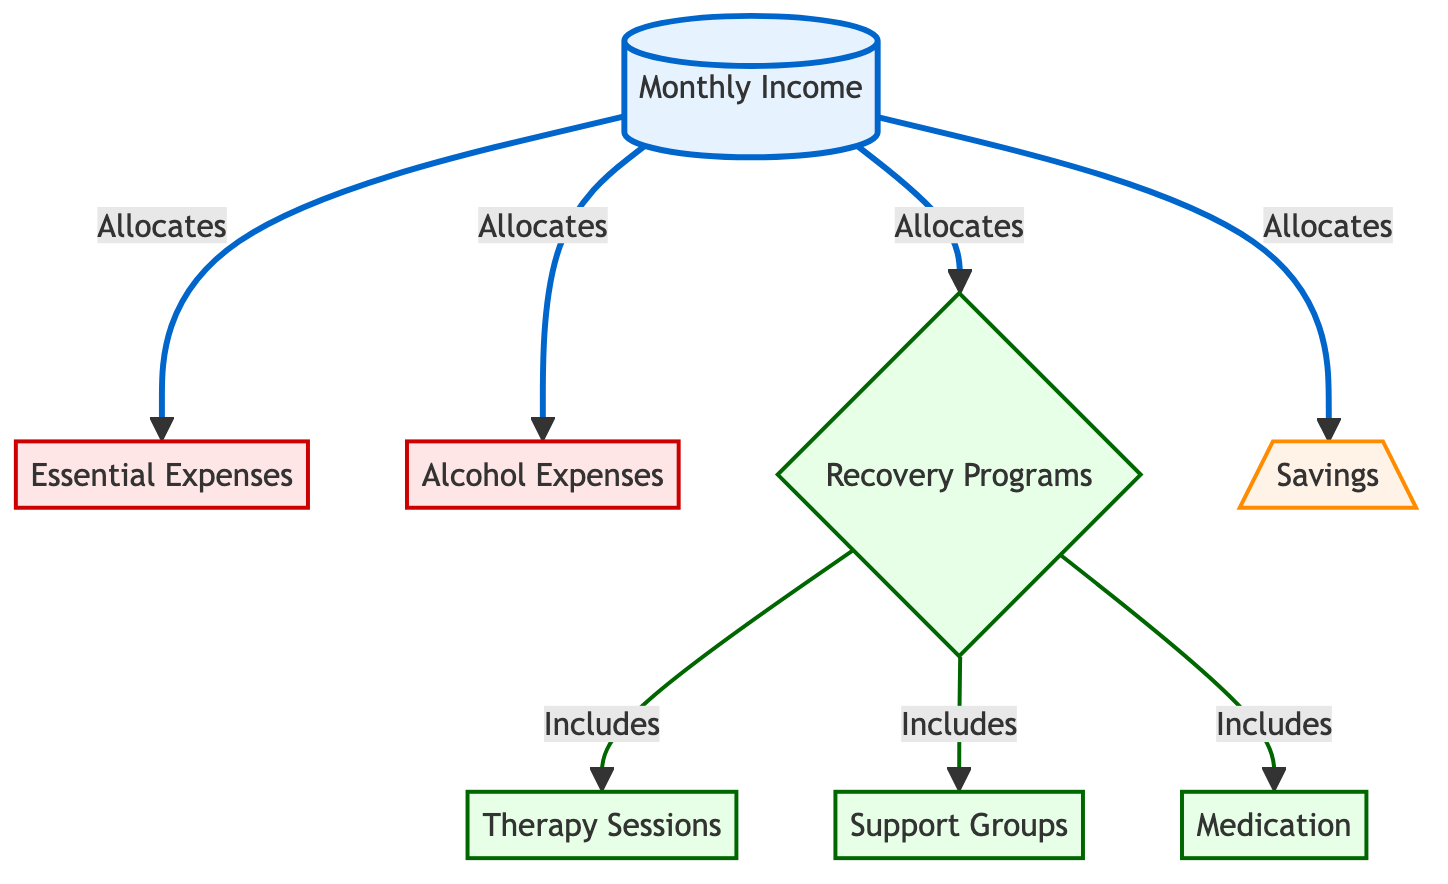What's the total number of nodes in the diagram? The diagram contains five distinct nodes: Monthly Income, Essential Expenses, Alcohol Expenses, Recovery Programs, and Savings.
Answer: 5 What type of expenses is included under the "Recovery Programs" node? The "Recovery Programs" node includes three types of expenses: Therapy Sessions, Support Groups, and Medication, which are all connected to the main node of Recovery Programs.
Answer: Therapy Sessions, Support Groups, Medication How many types of recovery expenses are listed in the diagram? There are three types of recovery expenses listed under the Recovery Programs node: Therapy Sessions, Support Groups, and Medication. Each of these is connected to the Recovery Programs node, indicating they fall under the same category.
Answer: 3 Which nodes have a direct allocation from the "Monthly Income" node? The nodes that have a direct allocation from the "Monthly Income" node are Essential Expenses, Alcohol Expenses, Recovery Programs, and Savings. These are all directly connected to Monthly Income through outgoing edges.
Answer: Essential Expenses, Alcohol Expenses, Recovery Programs, Savings What is the color representing the "Recovery Programs" node? The "Recovery Programs" node is represented by green in the diagram, indicating a class defined for recovery expenses based on a specific styling.
Answer: Green How is the relationship between "Recovery Programs" and its components structured? The "Recovery Programs" node has a direct inclusion relationship with its components: Therapy Sessions, Support Groups, and Medication, which are included under Recovery Programs as essential elements of recovery expenses.
Answer: Inclusive What type of expenses does the "Alcohol Expenses" node represent? The "Alcohol Expenses" node represents optional or non-essential expenses linked to alcohol consumption, highlighted in red in the diagram for clarity on its nature as an expense category.
Answer: Non-essential How many types of edges are present in the diagram? The diagram has two types of edges: allocations (shown in blue for regular expenses from Monthly Income) and inclusions (shown in green for items under Recovery Programs), resulting in two distinct edge types.
Answer: 2 What is the main purpose of the "Savings" node in the diagram? The "Savings" node serves to allocate part of the Monthly Income toward saving, indicated as an important financial category highlighting resource management alongside expenses such as Alcohol and Recovery Programs.
Answer: Saving 